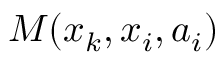<formula> <loc_0><loc_0><loc_500><loc_500>M ( x _ { k } , x _ { i } , a _ { i } )</formula> 